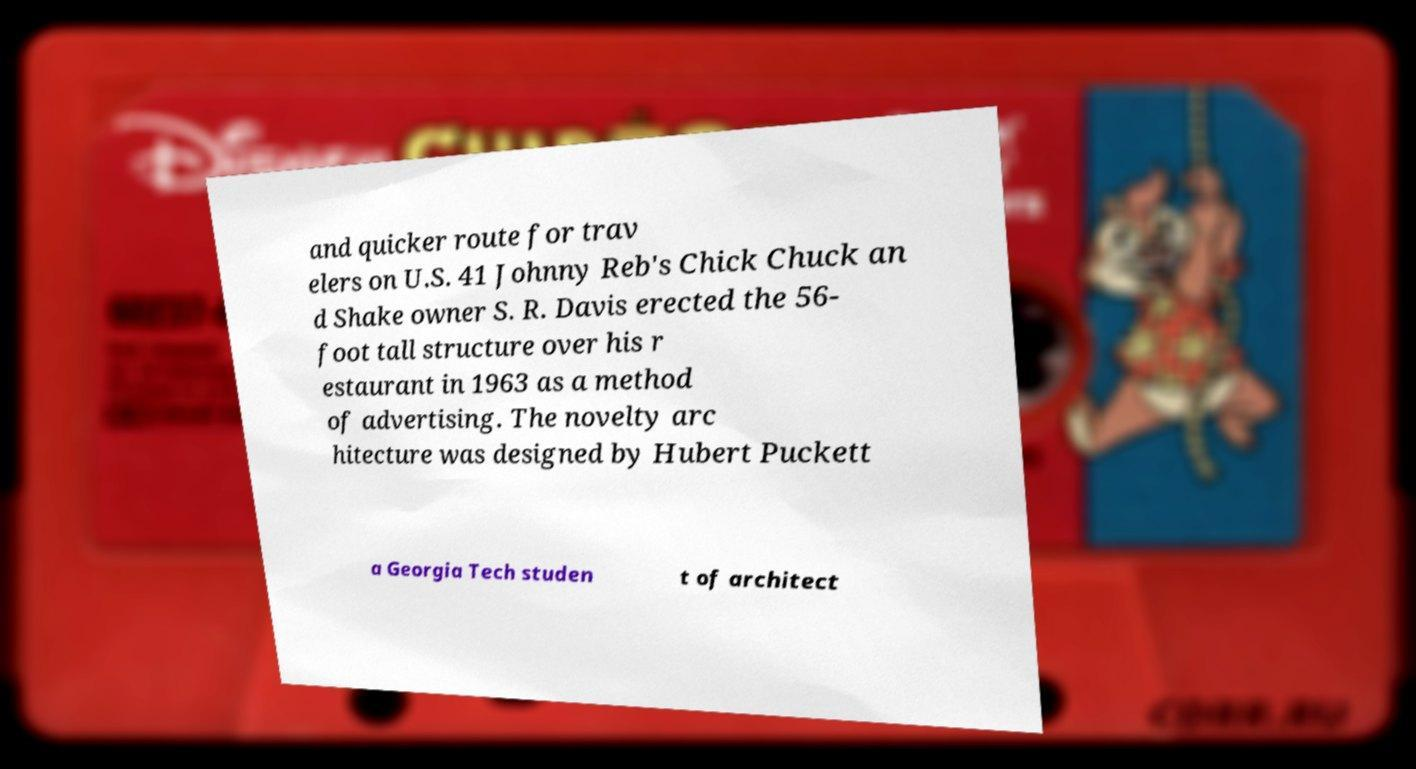There's text embedded in this image that I need extracted. Can you transcribe it verbatim? and quicker route for trav elers on U.S. 41 Johnny Reb's Chick Chuck an d Shake owner S. R. Davis erected the 56- foot tall structure over his r estaurant in 1963 as a method of advertising. The novelty arc hitecture was designed by Hubert Puckett a Georgia Tech studen t of architect 